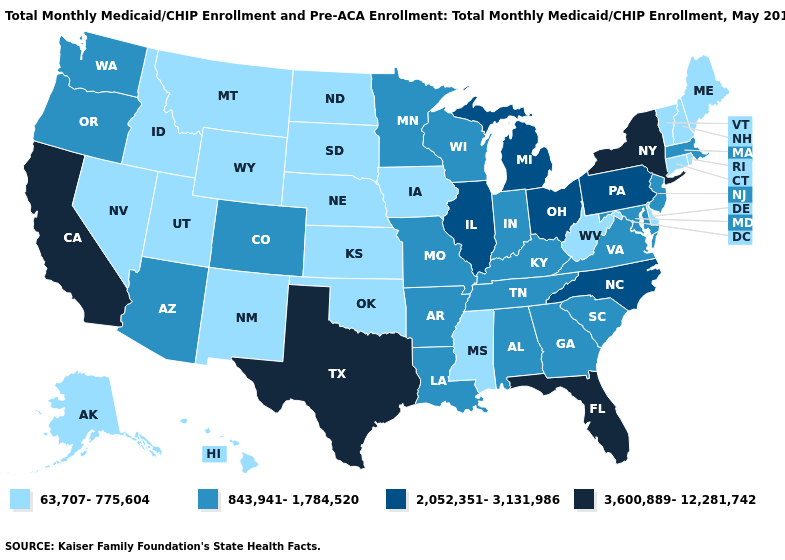Name the states that have a value in the range 2,052,351-3,131,986?
Answer briefly. Illinois, Michigan, North Carolina, Ohio, Pennsylvania. What is the value of Tennessee?
Short answer required. 843,941-1,784,520. Does Nevada have a lower value than New Mexico?
Concise answer only. No. Among the states that border Oklahoma , which have the highest value?
Give a very brief answer. Texas. Name the states that have a value in the range 2,052,351-3,131,986?
Short answer required. Illinois, Michigan, North Carolina, Ohio, Pennsylvania. Name the states that have a value in the range 843,941-1,784,520?
Answer briefly. Alabama, Arizona, Arkansas, Colorado, Georgia, Indiana, Kentucky, Louisiana, Maryland, Massachusetts, Minnesota, Missouri, New Jersey, Oregon, South Carolina, Tennessee, Virginia, Washington, Wisconsin. Does New York have the highest value in the Northeast?
Write a very short answer. Yes. What is the highest value in the USA?
Be succinct. 3,600,889-12,281,742. Among the states that border Maryland , which have the highest value?
Answer briefly. Pennsylvania. What is the value of Maryland?
Be succinct. 843,941-1,784,520. Among the states that border Michigan , does Wisconsin have the highest value?
Short answer required. No. What is the value of Oklahoma?
Concise answer only. 63,707-775,604. Among the states that border Missouri , which have the lowest value?
Give a very brief answer. Iowa, Kansas, Nebraska, Oklahoma. What is the lowest value in states that border Iowa?
Quick response, please. 63,707-775,604. Does Kentucky have a higher value than Wisconsin?
Be succinct. No. 